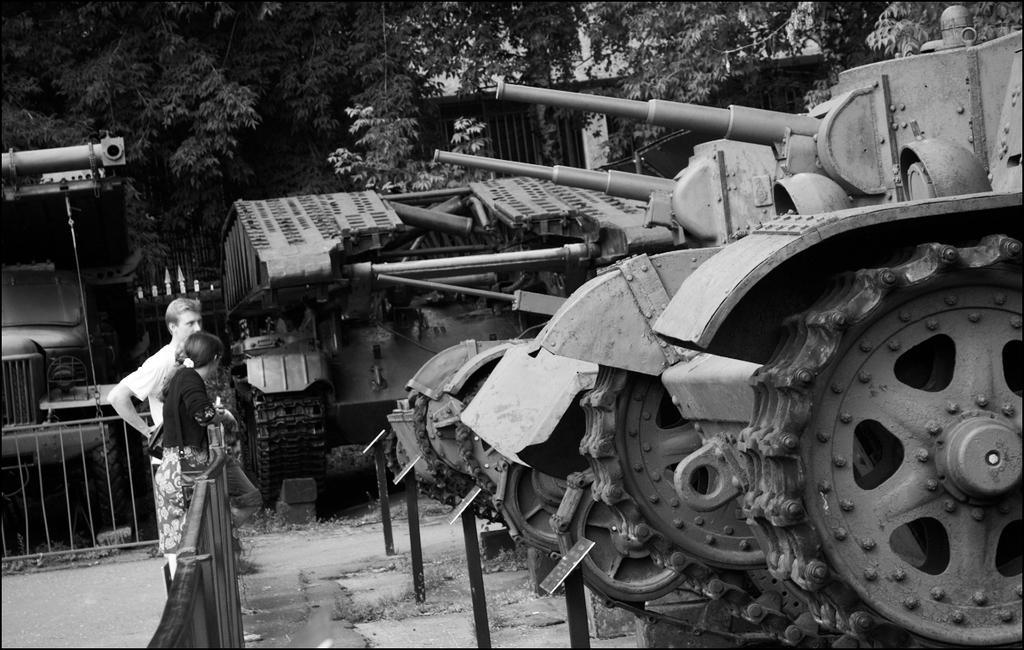How would you summarize this image in a sentence or two? This is a black and white image. I can see the man and woman standing. These look like barricades. I can see the battle tanks. This looks like a truck. These are the trees. I can see the boards attached to the poles. 